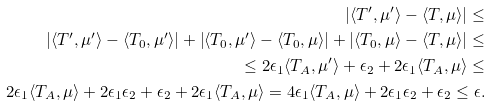<formula> <loc_0><loc_0><loc_500><loc_500>\left | \langle T ^ { \prime } , \mu ^ { \prime } \rangle - \langle T , \mu \rangle \right | \leq \\ \left | \langle T ^ { \prime } , \mu ^ { \prime } \rangle - \langle T _ { 0 } , \mu ^ { \prime } \rangle \right | + \left | \langle T _ { 0 } , \mu ^ { \prime } \rangle - \langle T _ { 0 } , \mu \rangle \right | + \left | \langle T _ { 0 } , \mu \rangle - \langle T , \mu \rangle \right | \leq \\ \leq 2 \epsilon _ { 1 } \langle T _ { A } , \mu ^ { \prime } \rangle + \epsilon _ { 2 } + 2 \epsilon _ { 1 } \langle T _ { A } , \mu \rangle \leq \\ 2 \epsilon _ { 1 } \langle T _ { A } , \mu \rangle + 2 \epsilon _ { 1 } \epsilon _ { 2 } + \epsilon _ { 2 } + 2 \epsilon _ { 1 } \langle T _ { A } , \mu \rangle = 4 \epsilon _ { 1 } \langle T _ { A } , \mu \rangle + 2 \epsilon _ { 1 } \epsilon _ { 2 } + \epsilon _ { 2 } \leq \epsilon .</formula> 